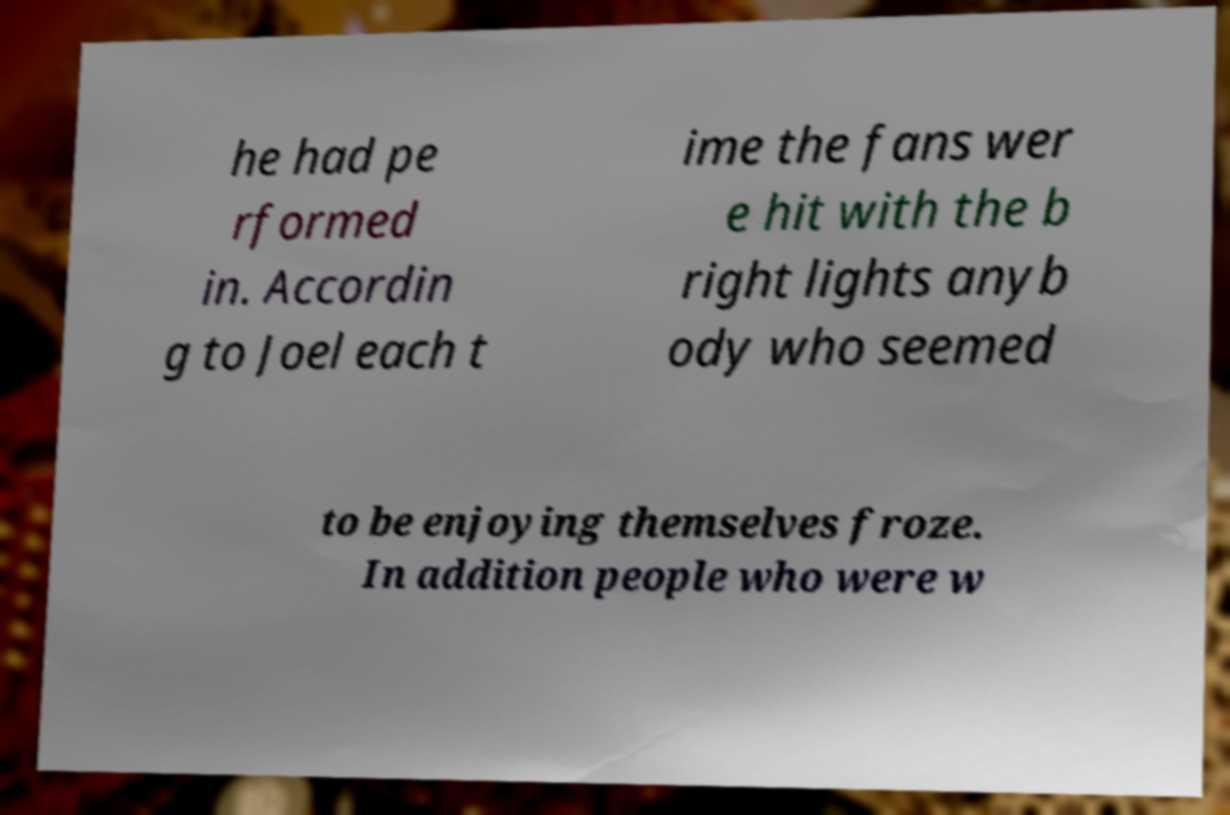Please identify and transcribe the text found in this image. he had pe rformed in. Accordin g to Joel each t ime the fans wer e hit with the b right lights anyb ody who seemed to be enjoying themselves froze. In addition people who were w 